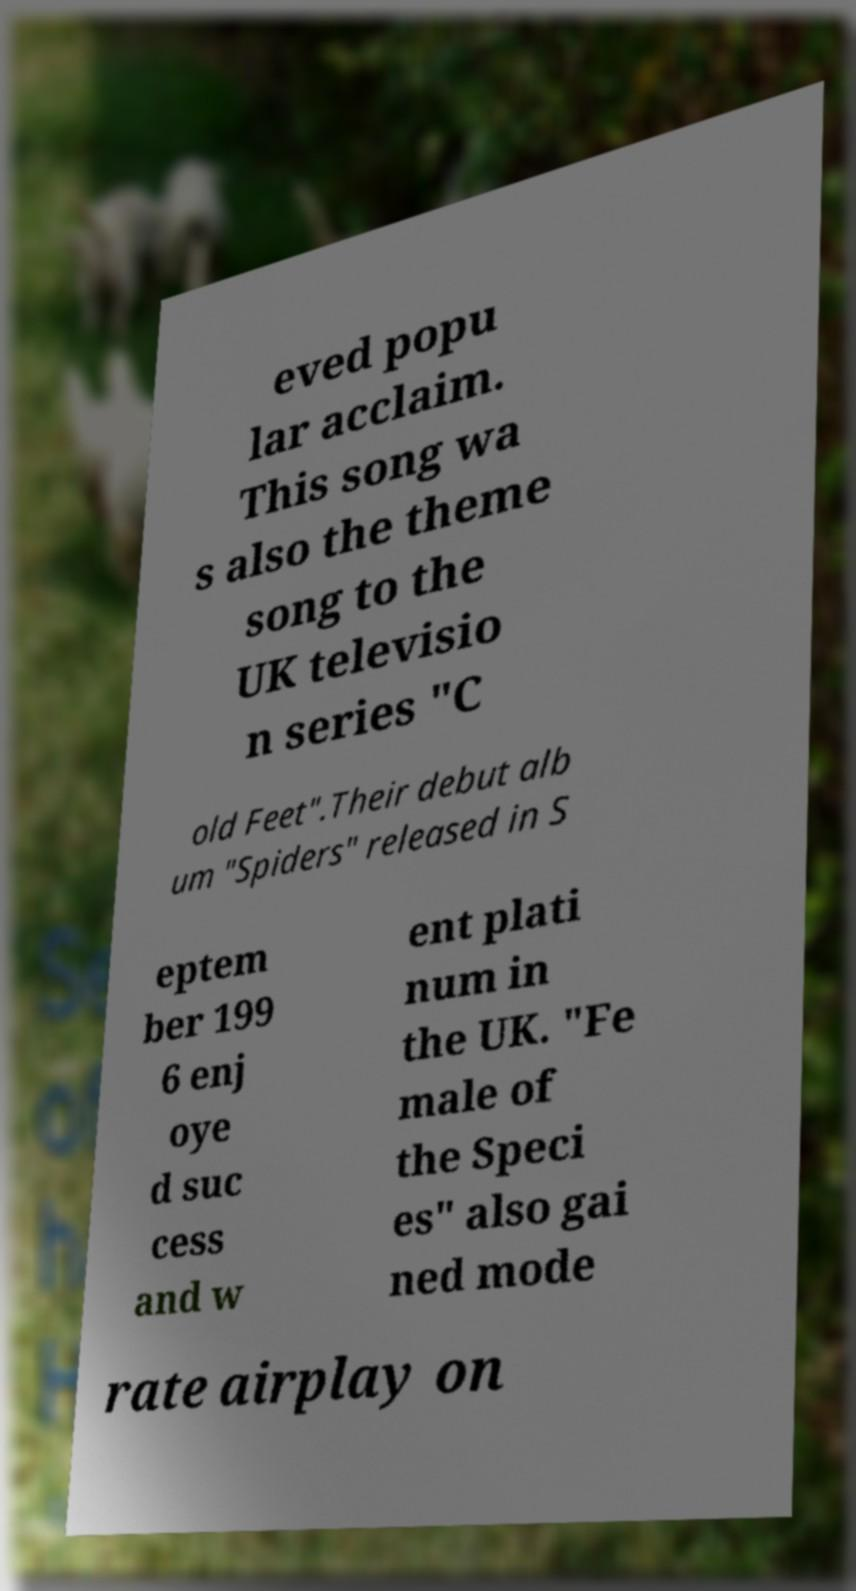Can you read and provide the text displayed in the image?This photo seems to have some interesting text. Can you extract and type it out for me? eved popu lar acclaim. This song wa s also the theme song to the UK televisio n series "C old Feet".Their debut alb um "Spiders" released in S eptem ber 199 6 enj oye d suc cess and w ent plati num in the UK. "Fe male of the Speci es" also gai ned mode rate airplay on 